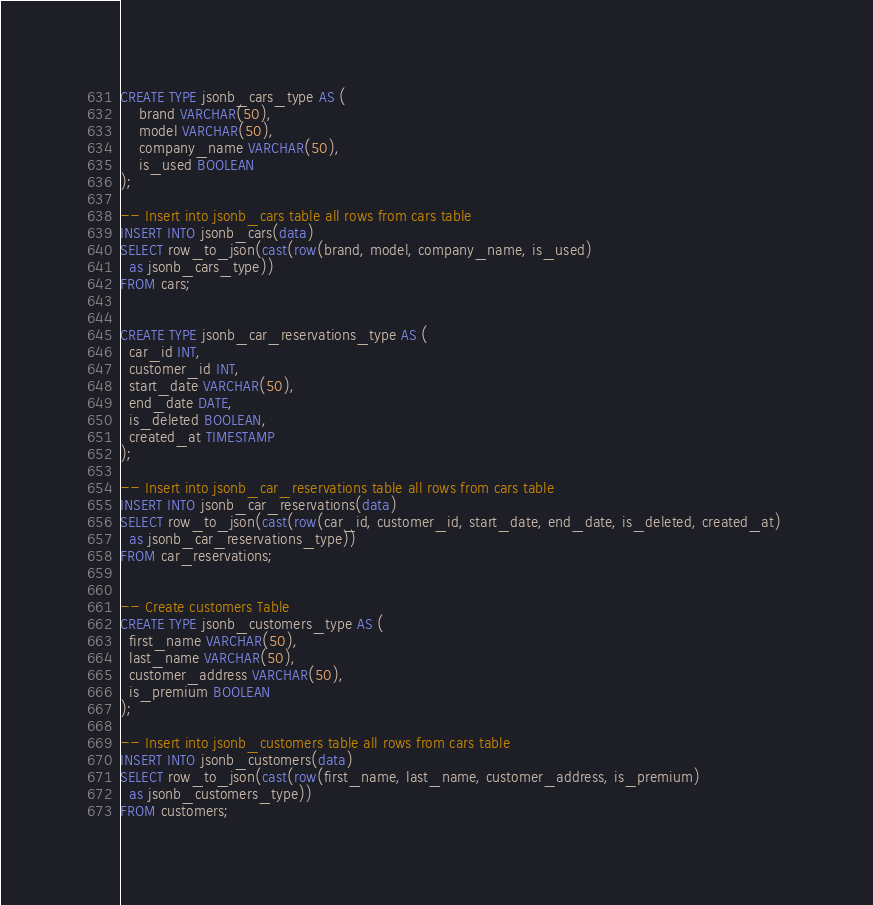Convert code to text. <code><loc_0><loc_0><loc_500><loc_500><_SQL_>CREATE TYPE jsonb_cars_type AS (
    brand VARCHAR(50),
    model VARCHAR(50),
    company_name VARCHAR(50),
    is_used BOOLEAN
);

-- Insert into jsonb_cars table all rows from cars table    
INSERT INTO jsonb_cars(data) 
SELECT row_to_json(cast(row(brand, model, company_name, is_used) 
  as jsonb_cars_type)) 
FROM cars;


CREATE TYPE jsonb_car_reservations_type AS (
  car_id INT,
  customer_id INT,
  start_date VARCHAR(50),
  end_date DATE,
  is_deleted BOOLEAN,
  created_at TIMESTAMP
);

-- Insert into jsonb_car_reservations table all rows from cars table    
INSERT INTO jsonb_car_reservations(data) 
SELECT row_to_json(cast(row(car_id, customer_id, start_date, end_date, is_deleted, created_at) 
  as jsonb_car_reservations_type)) 
FROM car_reservations;


-- Create customers Table
CREATE TYPE jsonb_customers_type AS (
  first_name VARCHAR(50),
  last_name VARCHAR(50),
  customer_address VARCHAR(50),
  is_premium BOOLEAN
);

-- Insert into jsonb_customers table all rows from cars table    
INSERT INTO jsonb_customers(data) 
SELECT row_to_json(cast(row(first_name, last_name, customer_address, is_premium) 
  as jsonb_customers_type)) 
FROM customers;
</code> 